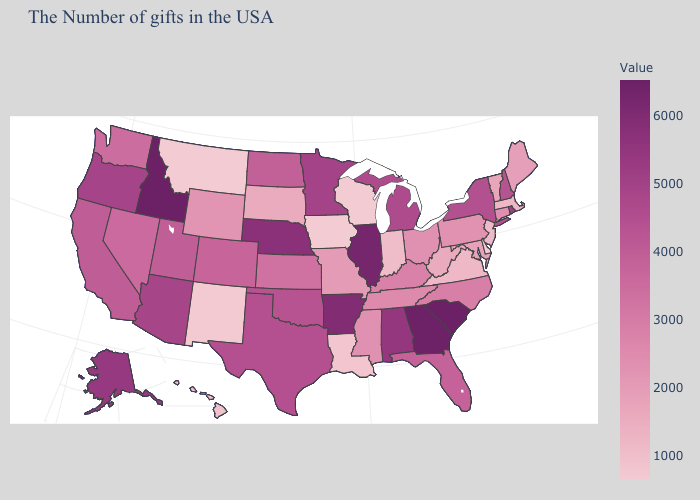Does Delaware have the lowest value in the USA?
Short answer required. Yes. Among the states that border New York , which have the highest value?
Be succinct. Connecticut. Which states have the lowest value in the South?
Quick response, please. Delaware. Which states have the highest value in the USA?
Give a very brief answer. South Carolina, Idaho. Does Wisconsin have the lowest value in the USA?
Concise answer only. Yes. Does Rhode Island have the lowest value in the USA?
Keep it brief. No. Is the legend a continuous bar?
Give a very brief answer. Yes. Which states hav the highest value in the West?
Keep it brief. Idaho. 